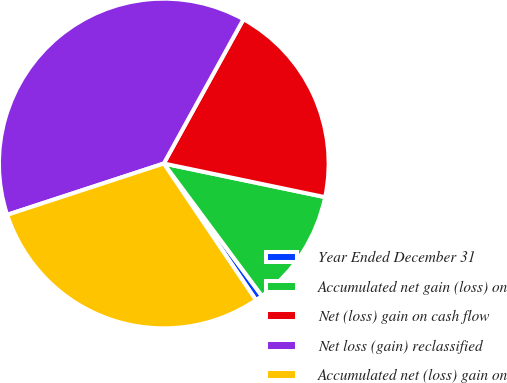Convert chart. <chart><loc_0><loc_0><loc_500><loc_500><pie_chart><fcel>Year Ended December 31<fcel>Accumulated net gain (loss) on<fcel>Net (loss) gain on cash flow<fcel>Net loss (gain) reclassified<fcel>Accumulated net (loss) gain on<nl><fcel>0.7%<fcel>11.58%<fcel>20.24%<fcel>38.07%<fcel>29.41%<nl></chart> 